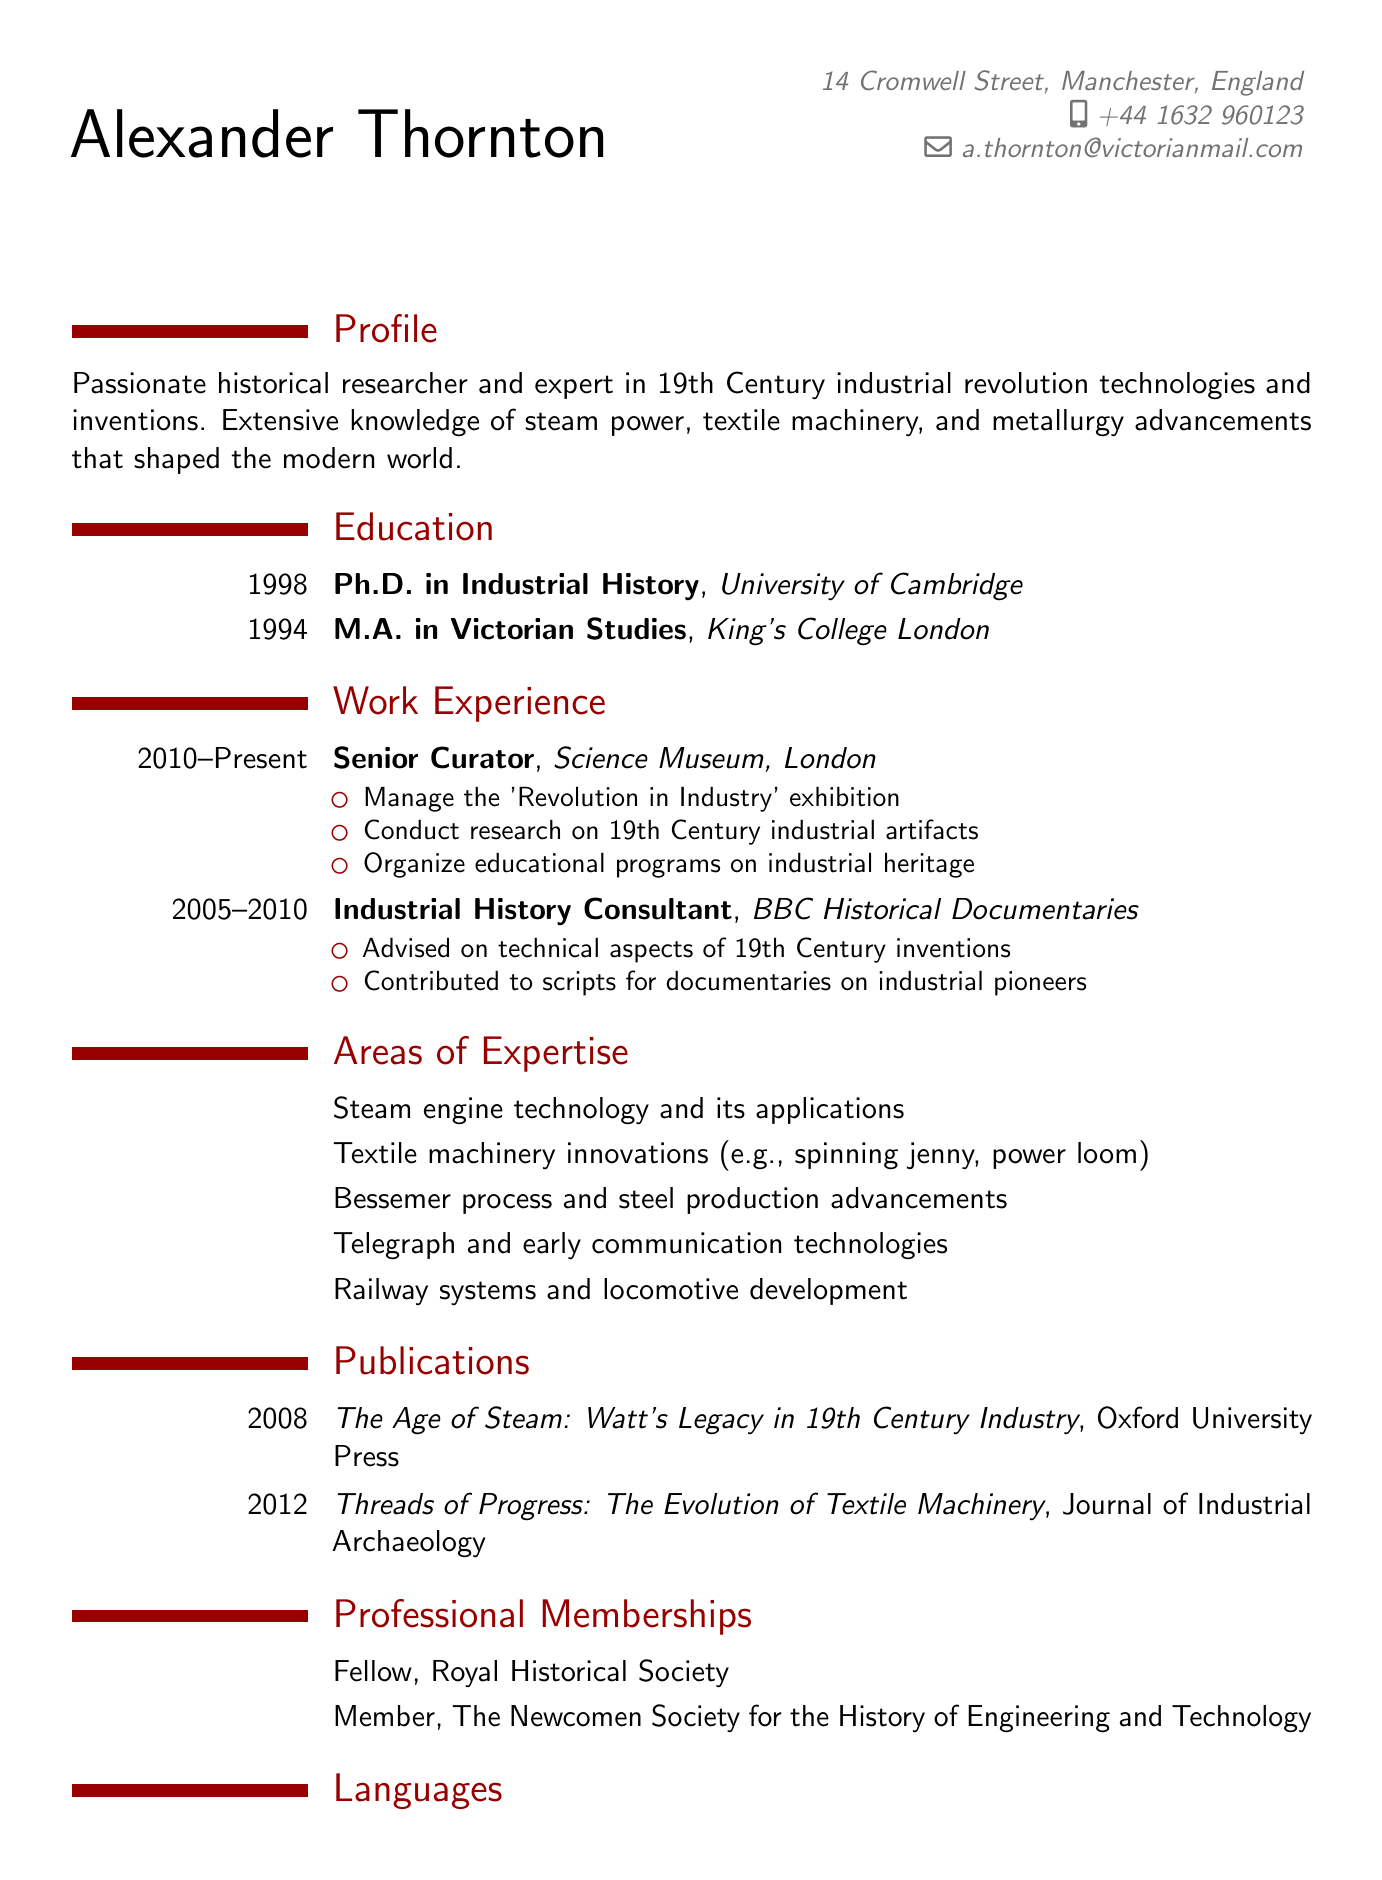What is the full name of the individual? The full name is presented at the top of the CV, which is "Alexander Thornton."
Answer: Alexander Thornton Which institution awarded Alexander his Ph.D.? The education section lists the University of Cambridge as the institution that awarded his Ph.D.
Answer: University of Cambridge What year did Alexander begin working at the Science Museum? The work experience section states he has been at the Science Museum since 2010.
Answer: 2010 Name one of Alexander's publications. The publications section includes titles, one of which is "The Age of Steam: Watt's Legacy in 19th Century Industry."
Answer: The Age of Steam: Watt's Legacy in 19th Century Industry Which society is Alexander a fellow of? The professional memberships section reveals he is a fellow of the Royal Historical Society.
Answer: Royal Historical Society What is one area of expertise listed in the CV? The areas of expertise section includes steam engine technology, which is one listed area.
Answer: Steam engine technology How many languages does Alexander speak? The languages section shows that he speaks three languages.
Answer: Three What type of degree did Alexander earn from King's College London? The education section specifies that he earned an M.A. from King's College London.
Answer: M.A 